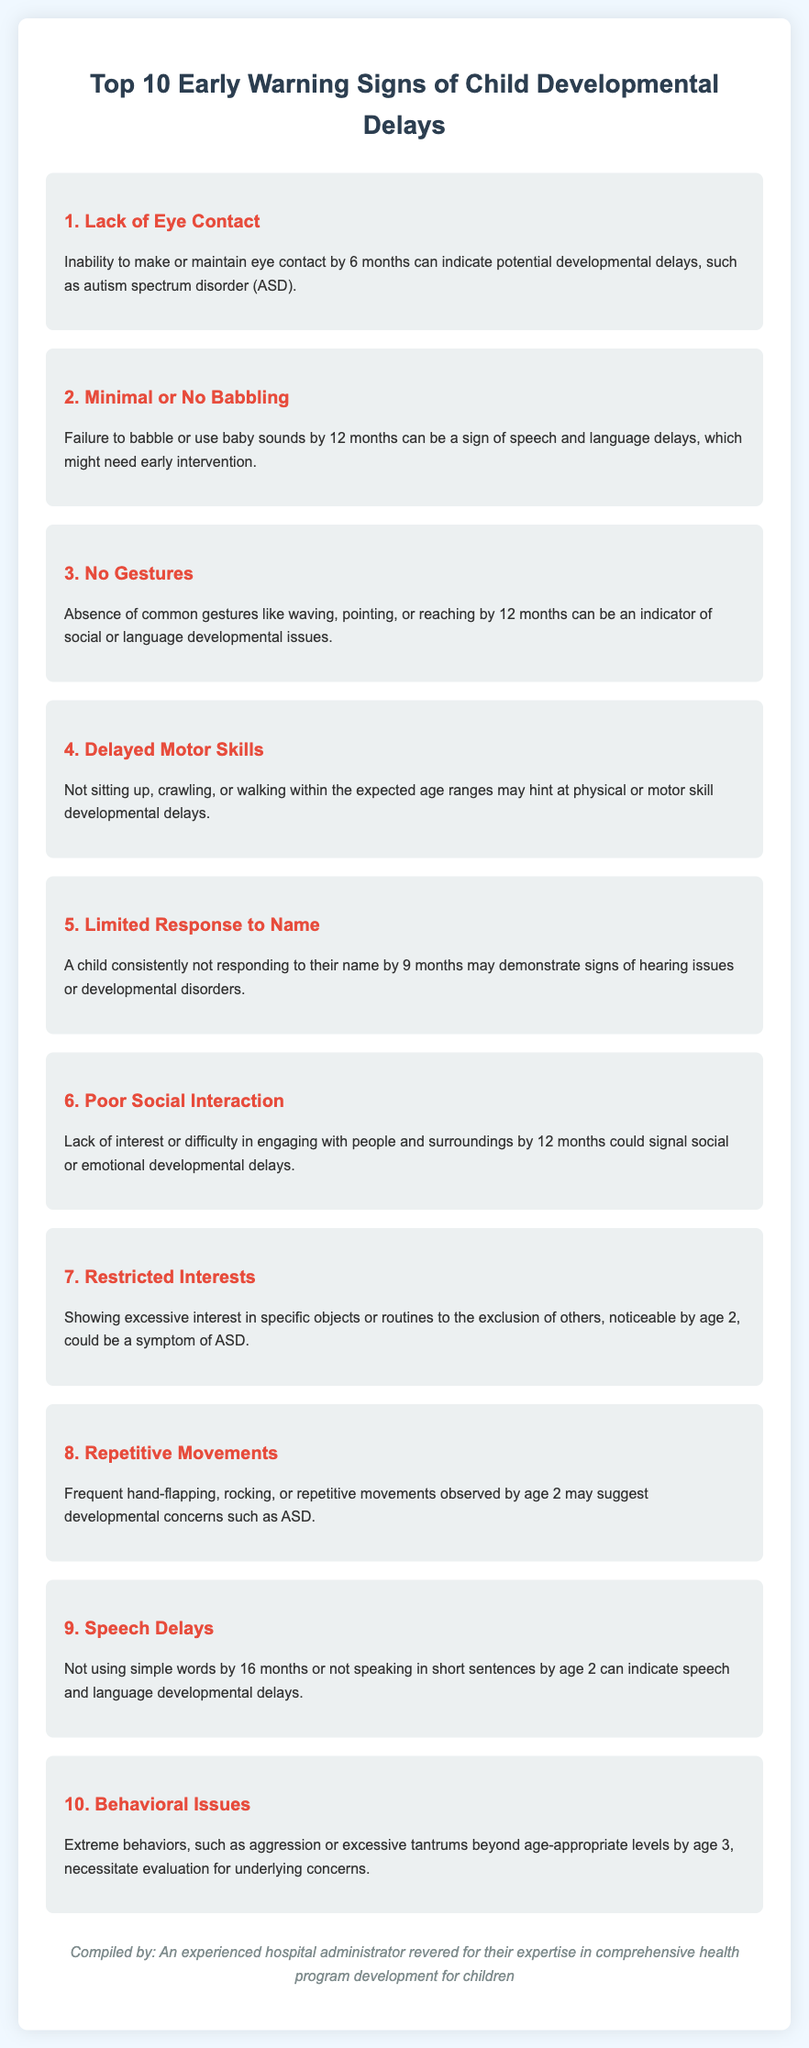what is the first warning sign of developmental delays? The first warning sign listed in the document is a lack of eye contact.
Answer: Lack of Eye Contact at what age should a child start to babble? The document states that a child should start to babble by 12 months of age.
Answer: 12 months how many warning signs are listed in the document? The document explicitly mentions a total of ten early warning signs.
Answer: 10 what behavior is a sign of poor social interaction? Difficulty in engaging with people and surroundings by 12 months is noted as a sign of poor social interaction.
Answer: Lack of interest which warning sign indicates potential speech and language delays? The failure to babble or use baby sounds by 12 months can indicate speech and language delays.
Answer: Minimal or No Babbling what repeated behaviors might suggest developmental concerns? Frequent hand-flapping, rocking, or repetitive movements may suggest developmental concerns.
Answer: Repetitive Movements how old should a child be to respond to their name? The document mentions that a child should respond to their name by 9 months.
Answer: 9 months what is a symptom of ASD mentioned in the document? Showing excessive interest in specific objects or routines to the exclusion of others is mentioned as a symptom of ASD.
Answer: Restricted Interests 